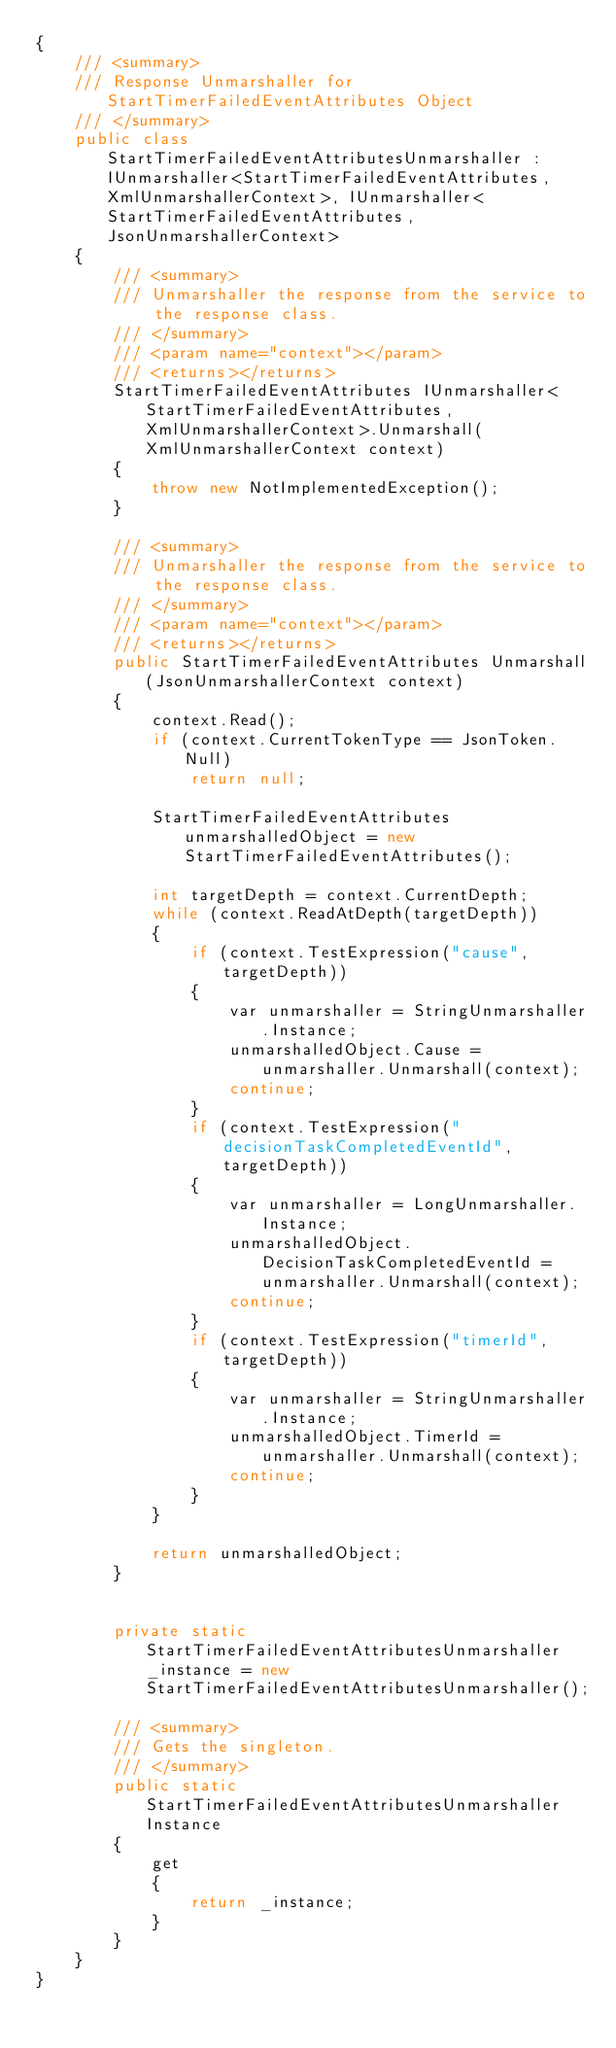Convert code to text. <code><loc_0><loc_0><loc_500><loc_500><_C#_>{
    /// <summary>
    /// Response Unmarshaller for StartTimerFailedEventAttributes Object
    /// </summary>  
    public class StartTimerFailedEventAttributesUnmarshaller : IUnmarshaller<StartTimerFailedEventAttributes, XmlUnmarshallerContext>, IUnmarshaller<StartTimerFailedEventAttributes, JsonUnmarshallerContext>
    {
        /// <summary>
        /// Unmarshaller the response from the service to the response class.
        /// </summary>  
        /// <param name="context"></param>
        /// <returns></returns>
        StartTimerFailedEventAttributes IUnmarshaller<StartTimerFailedEventAttributes, XmlUnmarshallerContext>.Unmarshall(XmlUnmarshallerContext context)
        {
            throw new NotImplementedException();
        }

        /// <summary>
        /// Unmarshaller the response from the service to the response class.
        /// </summary>  
        /// <param name="context"></param>
        /// <returns></returns>
        public StartTimerFailedEventAttributes Unmarshall(JsonUnmarshallerContext context)
        {
            context.Read();
            if (context.CurrentTokenType == JsonToken.Null) 
                return null;

            StartTimerFailedEventAttributes unmarshalledObject = new StartTimerFailedEventAttributes();
        
            int targetDepth = context.CurrentDepth;
            while (context.ReadAtDepth(targetDepth))
            {
                if (context.TestExpression("cause", targetDepth))
                {
                    var unmarshaller = StringUnmarshaller.Instance;
                    unmarshalledObject.Cause = unmarshaller.Unmarshall(context);
                    continue;
                }
                if (context.TestExpression("decisionTaskCompletedEventId", targetDepth))
                {
                    var unmarshaller = LongUnmarshaller.Instance;
                    unmarshalledObject.DecisionTaskCompletedEventId = unmarshaller.Unmarshall(context);
                    continue;
                }
                if (context.TestExpression("timerId", targetDepth))
                {
                    var unmarshaller = StringUnmarshaller.Instance;
                    unmarshalledObject.TimerId = unmarshaller.Unmarshall(context);
                    continue;
                }
            }
          
            return unmarshalledObject;
        }


        private static StartTimerFailedEventAttributesUnmarshaller _instance = new StartTimerFailedEventAttributesUnmarshaller();        

        /// <summary>
        /// Gets the singleton.
        /// </summary>  
        public static StartTimerFailedEventAttributesUnmarshaller Instance
        {
            get
            {
                return _instance;
            }
        }
    }
}</code> 